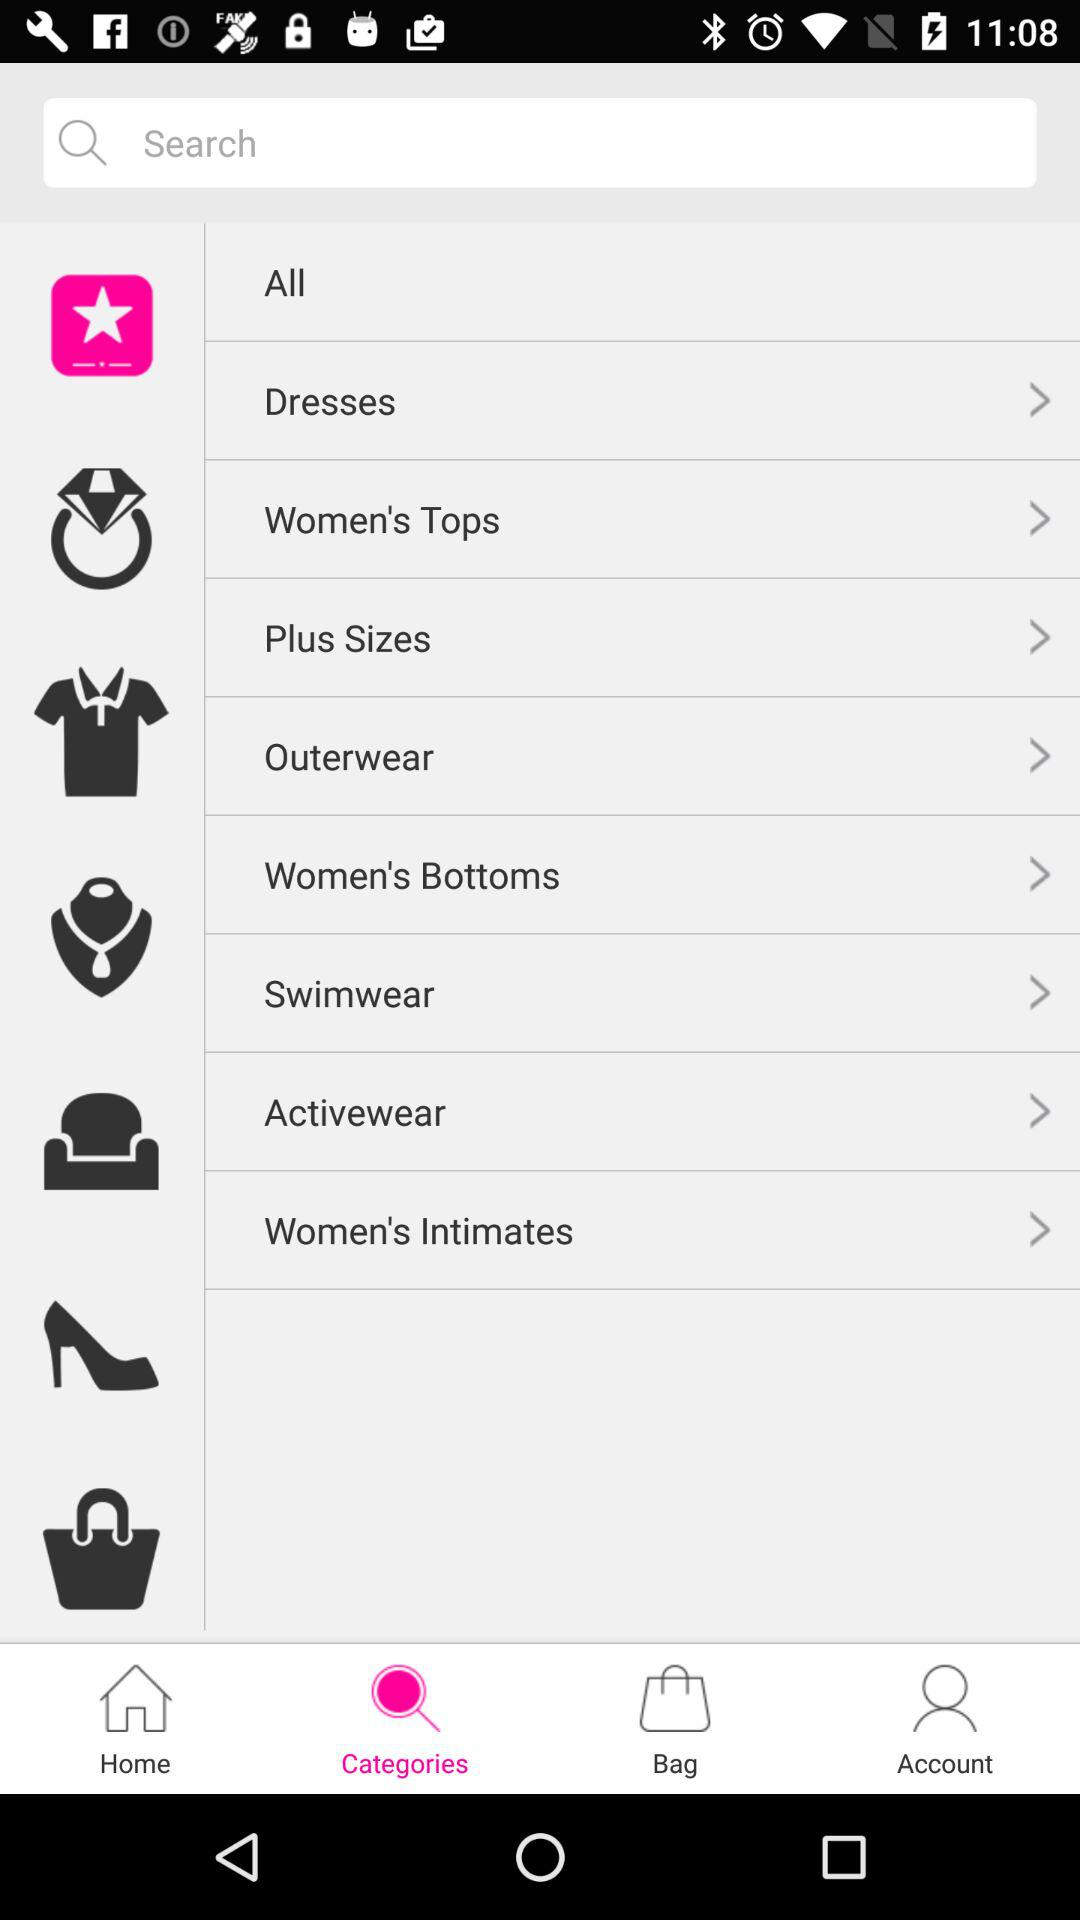What categories are available? The available categories are "Dresses", "Women's Tops", "Plus Sizes", "Outerwear", "Women's Bottoms", "Swimwear", "Activewear" and "Women's Intimates". 